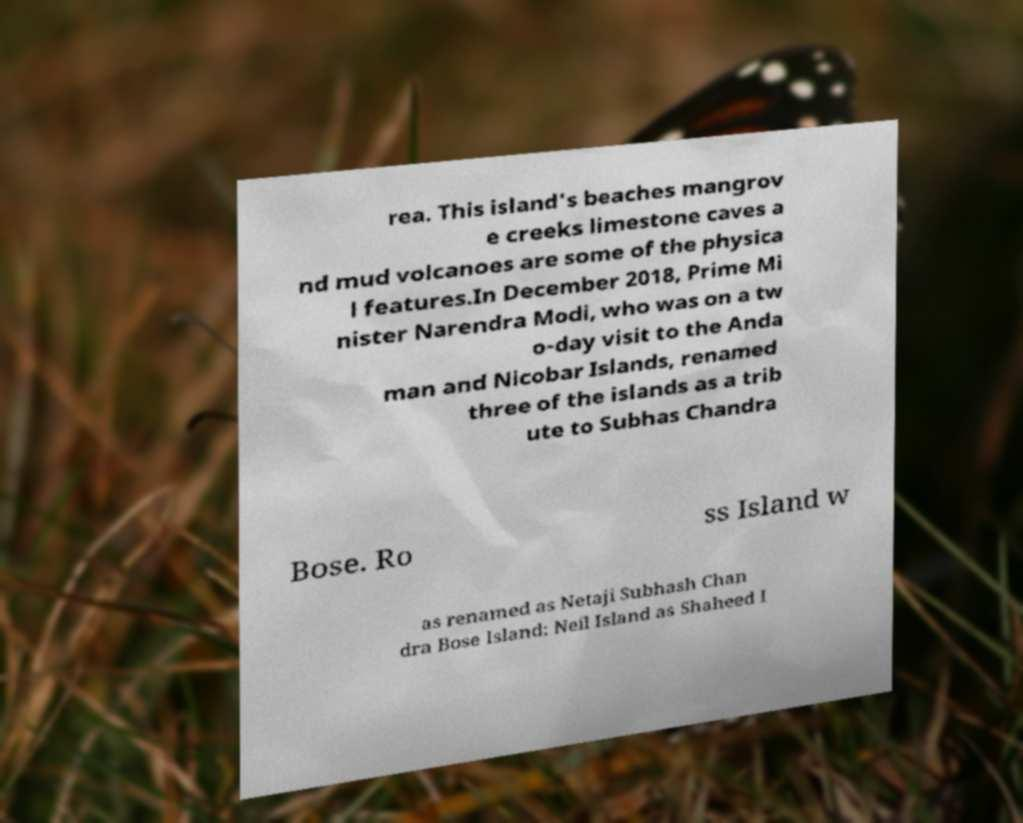There's text embedded in this image that I need extracted. Can you transcribe it verbatim? rea. This island's beaches mangrov e creeks limestone caves a nd mud volcanoes are some of the physica l features.In December 2018, Prime Mi nister Narendra Modi, who was on a tw o-day visit to the Anda man and Nicobar Islands, renamed three of the islands as a trib ute to Subhas Chandra Bose. Ro ss Island w as renamed as Netaji Subhash Chan dra Bose Island; Neil Island as Shaheed I 